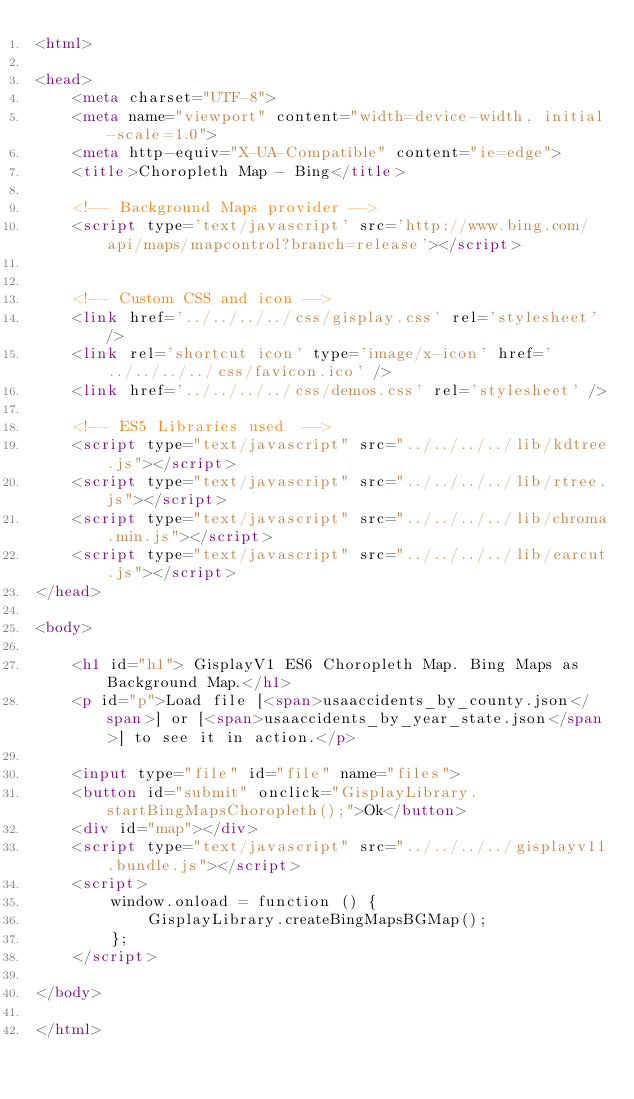<code> <loc_0><loc_0><loc_500><loc_500><_HTML_><html>

<head>
    <meta charset="UTF-8">
    <meta name="viewport" content="width=device-width, initial-scale=1.0">
    <meta http-equiv="X-UA-Compatible" content="ie=edge">
    <title>Choropleth Map - Bing</title>

    <!-- Background Maps provider -->
    <script type='text/javascript' src='http://www.bing.com/api/maps/mapcontrol?branch=release'></script>


    <!-- Custom CSS and icon -->
    <link href='../../../../css/gisplay.css' rel='stylesheet' />
    <link rel='shortcut icon' type='image/x-icon' href='../../../../css/favicon.ico' />
    <link href='../../../../css/demos.css' rel='stylesheet' />

    <!-- ES5 Libraries used  -->
    <script type="text/javascript" src="../../../../lib/kdtree.js"></script>
    <script type="text/javascript" src="../../../../lib/rtree.js"></script>
    <script type="text/javascript" src="../../../../lib/chroma.min.js"></script>
    <script type="text/javascript" src="../../../../lib/earcut.js"></script>
</head>

<body>

    <h1 id="h1"> GisplayV1 ES6 Choropleth Map. Bing Maps as Background Map.</h1>
    <p id="p">Load file [<span>usaaccidents_by_county.json</span>] or [<span>usaaccidents_by_year_state.json</span>] to see it in action.</p>

    <input type="file" id="file" name="files">
    <button id="submit" onclick="GisplayLibrary.startBingMapsChoropleth();">Ok</button>
    <div id="map"></div>
    <script type="text/javascript" src="../../../../gisplayv11.bundle.js"></script>
    <script>
        window.onload = function () {
            GisplayLibrary.createBingMapsBGMap();
        };
    </script>

</body>

</html></code> 